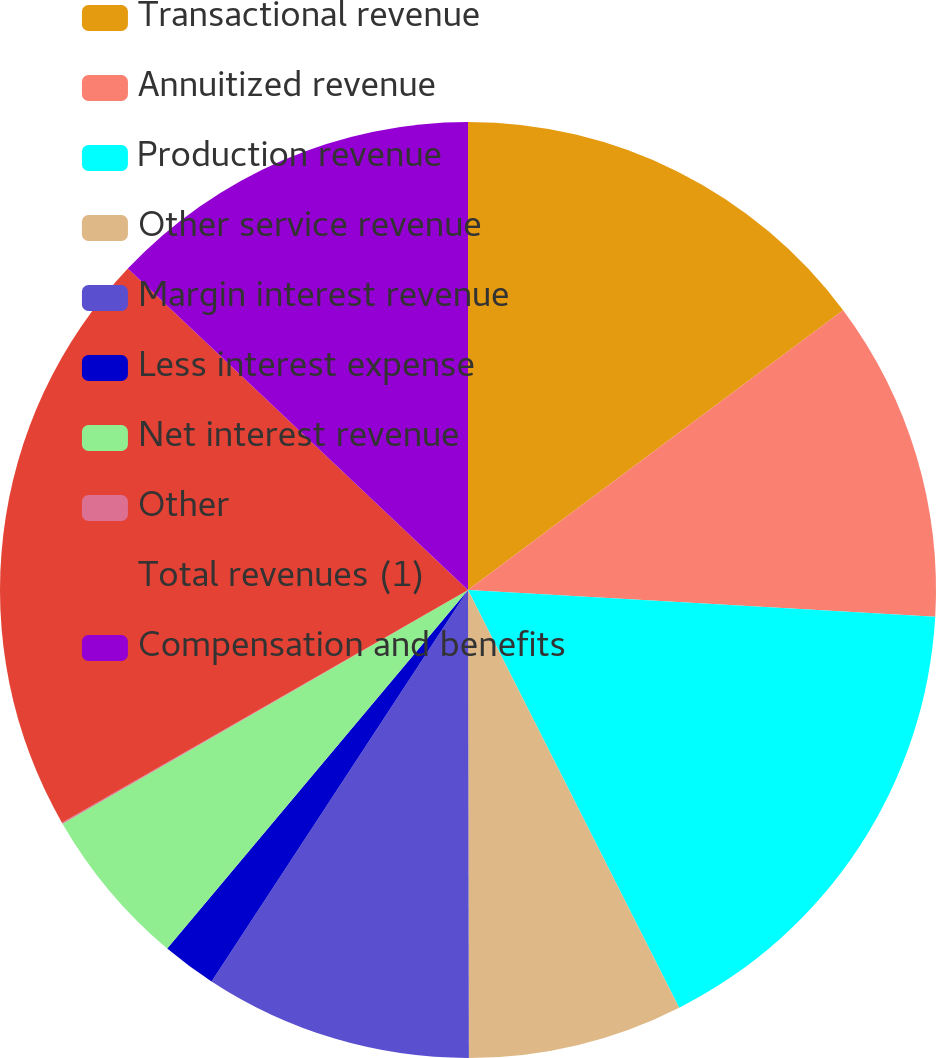Convert chart to OTSL. <chart><loc_0><loc_0><loc_500><loc_500><pie_chart><fcel>Transactional revenue<fcel>Annuitized revenue<fcel>Production revenue<fcel>Other service revenue<fcel>Margin interest revenue<fcel>Less interest expense<fcel>Net interest revenue<fcel>Other<fcel>Total revenues (1)<fcel>Compensation and benefits<nl><fcel>14.8%<fcel>11.11%<fcel>16.64%<fcel>7.42%<fcel>9.26%<fcel>1.88%<fcel>5.57%<fcel>0.04%<fcel>20.33%<fcel>12.95%<nl></chart> 